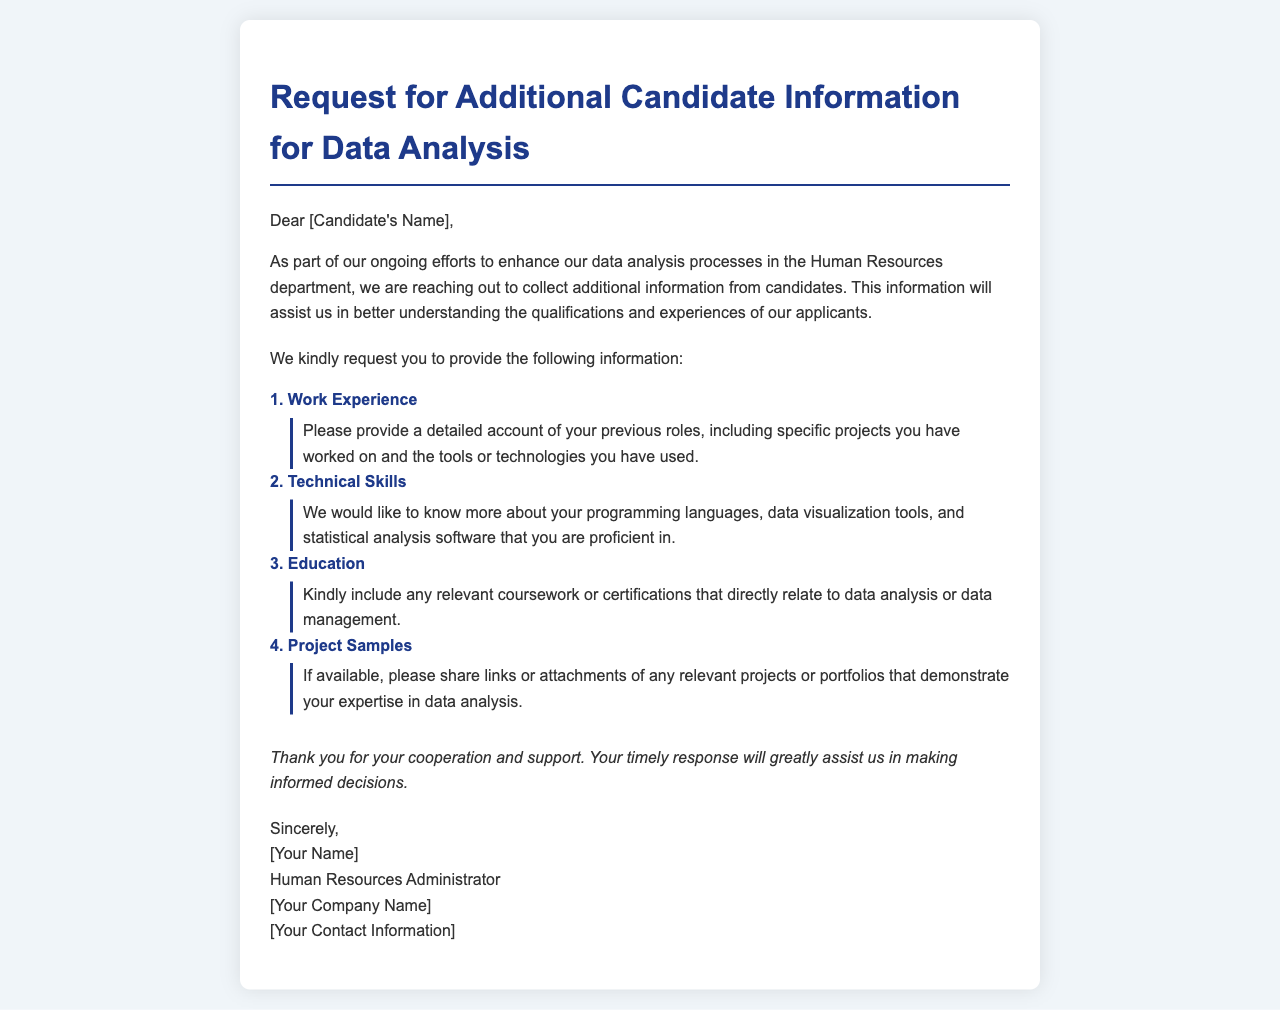What is the title of the document? The title can be found at the top of the document within the heading.
Answer: Request for Additional Candidate Information for Data Analysis Who is the letter addressed to? The recipient's name is indicated in the salutation section of the letter.
Answer: [Candidate's Name] What category asks for programming languages and tools? This information is specifically requested under the "Technical Skills" category.
Answer: Technical Skills What information is requested under the work experience category? Details regarding previous roles, projects, and tools or technologies used are requested.
Answer: Detailed account of previous roles What closing statement does the letter include? The closing expresses gratitude and highlights the importance of a timely response.
Answer: Thank you for your cooperation and support Who is signing the document? The signature section includes the sender's name and title.
Answer: [Your Name] 